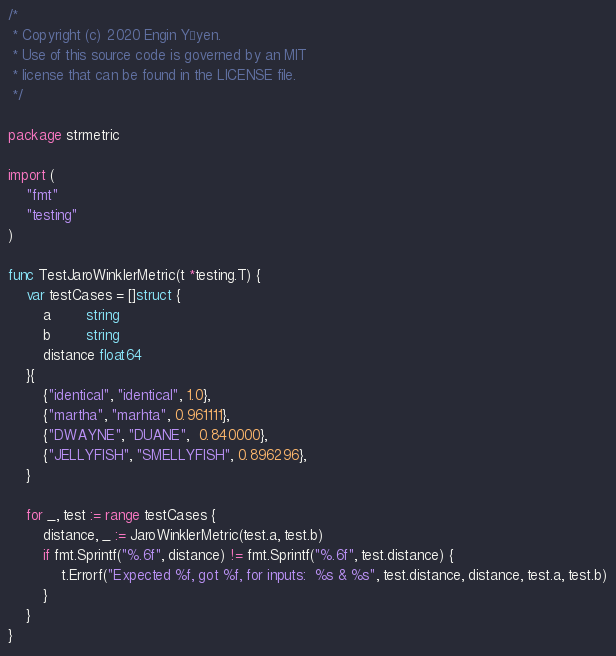<code> <loc_0><loc_0><loc_500><loc_500><_Go_>/*
 * Copyright (c) 2020 Engin Yöyen.
 * Use of this source code is governed by an MIT
 * license that can be found in the LICENSE file.
 */

package strmetric

import (
	"fmt"
	"testing"
)

func TestJaroWinklerMetric(t *testing.T) {
	var testCases = []struct {
		a        string
		b        string
		distance float64
	}{
		{"identical", "identical", 1.0},
		{"martha", "marhta", 0.961111},
		{"DWAYNE", "DUANE",  0.840000},
		{"JELLYFISH", "SMELLYFISH", 0.896296},
	}

	for _, test := range testCases {
		distance, _ := JaroWinklerMetric(test.a, test.b)
		if fmt.Sprintf("%.6f", distance) != fmt.Sprintf("%.6f", test.distance) {
			t.Errorf("Expected %f, got %f, for inputs:  %s & %s", test.distance, distance, test.a, test.b)
		}
	}
}
</code> 